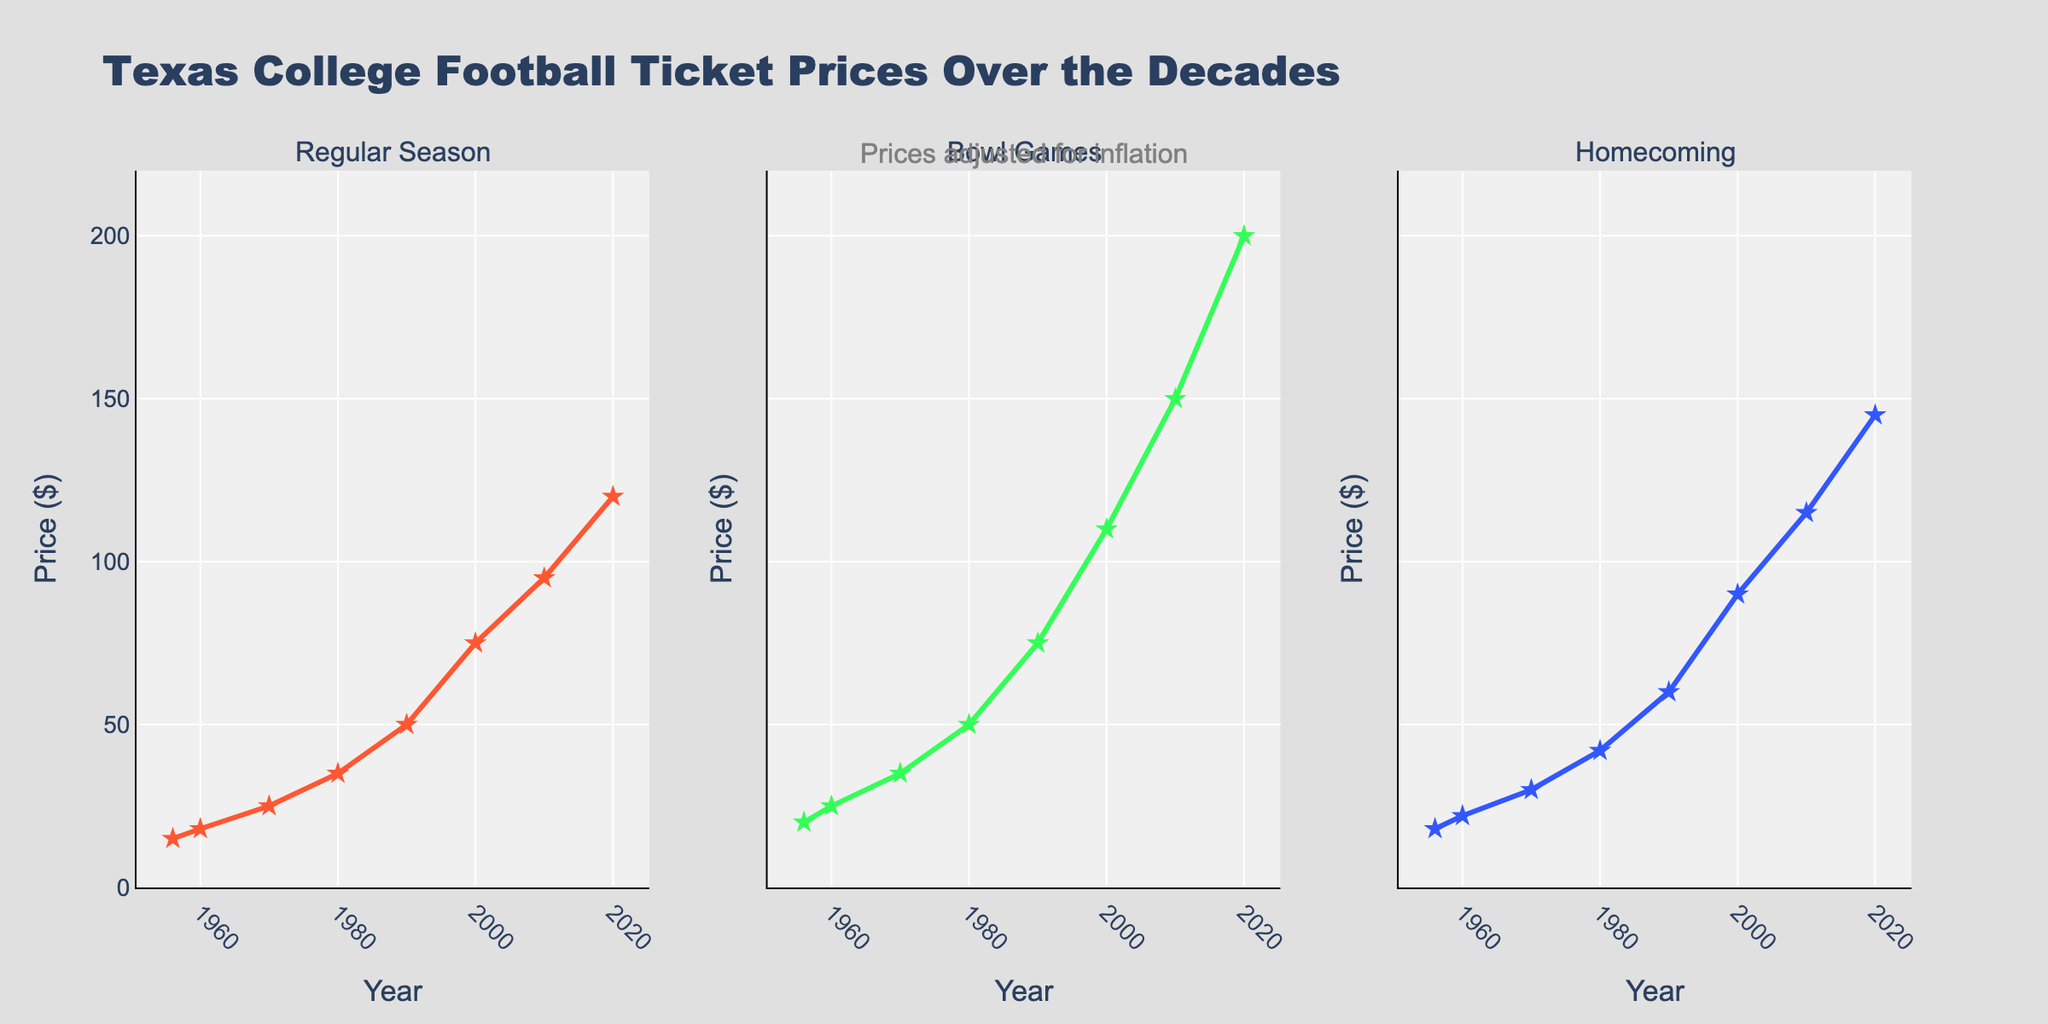What is the title of the figure? The title is located at the top center of the figure. It reads "Texas College Football Ticket Prices Over the Decades".
Answer: Texas College Football Ticket Prices Over the Decades How does the price trend for Regular Season games change from 1956 to 2020? From the figure, the line representing Regular Season games starts at $15 in 1956 and increases steadily to $120 by 2020. The line consistently rises over each decade.
Answer: The price increases steadily from $15 to $120 Which category saw the highest ticket price in 2020? By looking at the three subplots and comparing the final data points for each, we see that Bowl Games, indicated by the highest Y-values, had ticket prices of $200 in 2020.
Answer: Bowl Games How much did the average ticket prices for Homecoming games increase between 1956 and 2020? In 1956, the price for Homecoming was $18, and in 2020 it was $145. To find the increase, subtract $18 from $145, which equals $127.
Answer: $127 Compare the ticket price of Homecoming games to Regular Season games in 2000. Which was higher and by how much? In 2000, the Homecoming price was $90, and the Regular Season price was $75. The difference is $90 minus $75, which equals $15. Homecoming was higher by $15.
Answer: Homecoming was higher by $15 During which decade did Bowl Games see the most significant increase in ticket prices? By examining the slope of the lines representing Bowl Games across each decade, the largest increase appears to be between 2000 and 2010, where the price jumps from $110 to $150, a $40 increase.
Answer: 2000-2010 Which category had the steepest increase in ticket prices from the previous decade in the 1980s? In the 1980s, Regular Season prices increased from $25 to $35 ($10 increase), Bowl Games from $35 to $50 ($15 increase), and Homecoming from $30 to $42 ($12 increase). The steepest increase was for Bowl Games.
Answer: Bowl Games What was the average ticket price for all three categories in 1990? The prices in 1990 were $50 (Regular Season), $75 (Bowl Games), and $60 (Homecoming). The average is calculated as ($50 + $75 + $60) / 3 = $185 / 3 = approximately $61.67.
Answer: $61.67 What annotation is present in the figure to provide additional context about the prices? Located at the top of the figure, the annotation reads "Prices adjusted for inflation".
Answer: Prices adjusted for inflation Which decade saw the lowest ticket prices for Regular Season games? By looking at the subplot for Regular Season games, the lowest ticket prices occurred in 1956 at $15.
Answer: 1956 